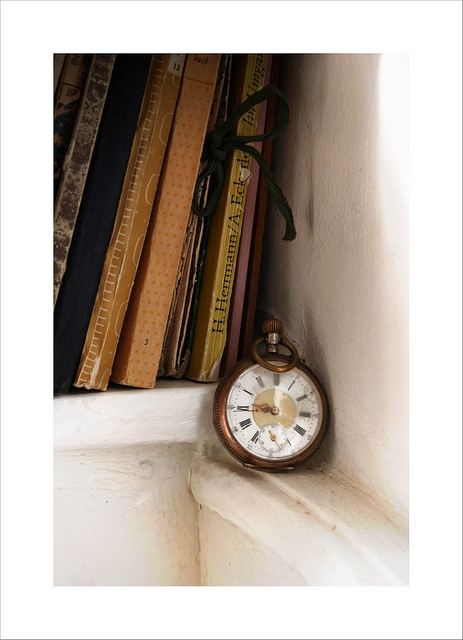Describe the objects in this image and their specific colors. I can see book in lightgray, brown, tan, and maroon tones, book in lightgray, brown, maroon, and black tones, book in lightgray, black, maroon, and gray tones, book in lightgray, black, maroon, and gray tones, and book in lightgray, black, maroon, and olive tones in this image. 